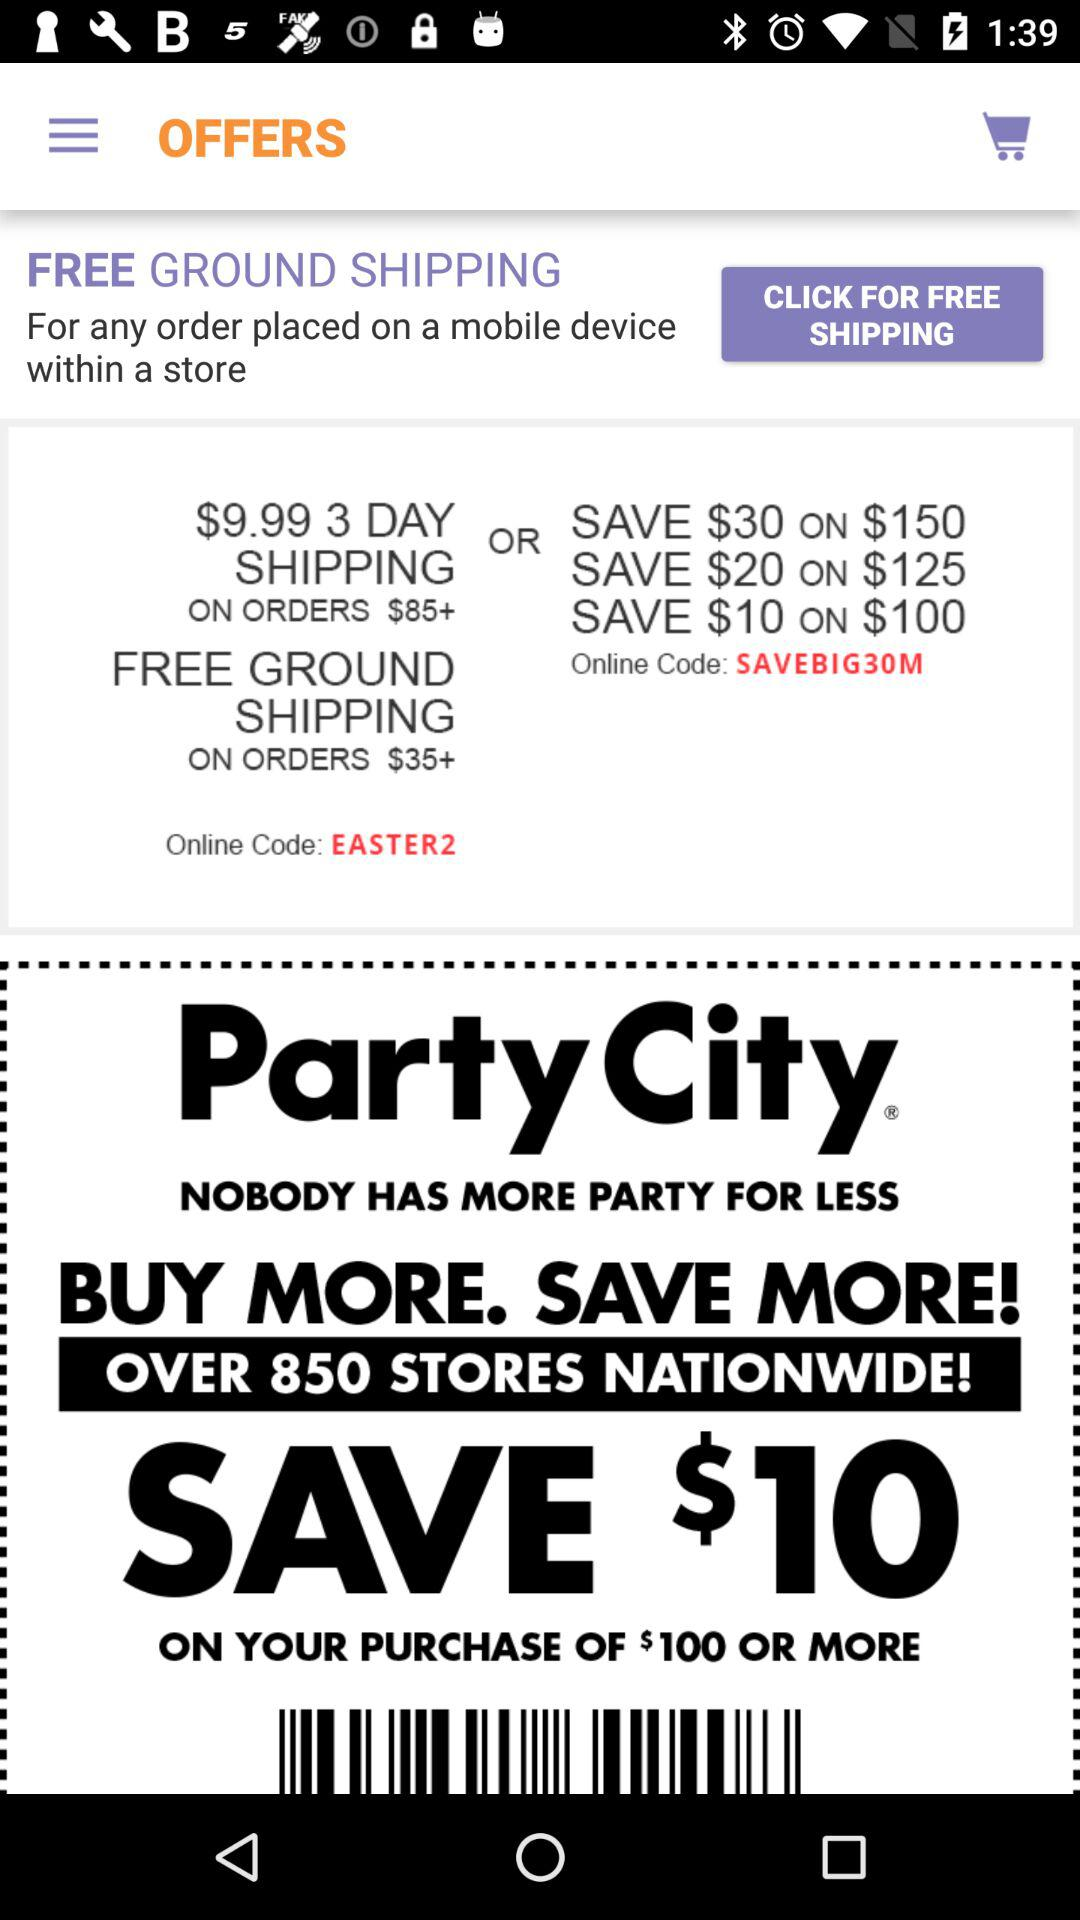What is the online code to save $30 on an order of $150? The online code is "SAVEBIG30M". 